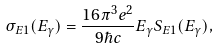<formula> <loc_0><loc_0><loc_500><loc_500>\sigma _ { E 1 } ( E _ { \gamma } ) = { \frac { { 1 6 \pi ^ { 3 } e ^ { 2 } } } { 9 \hbar { c } } } E _ { \gamma } S _ { E 1 } ( E _ { \gamma } ) ,</formula> 